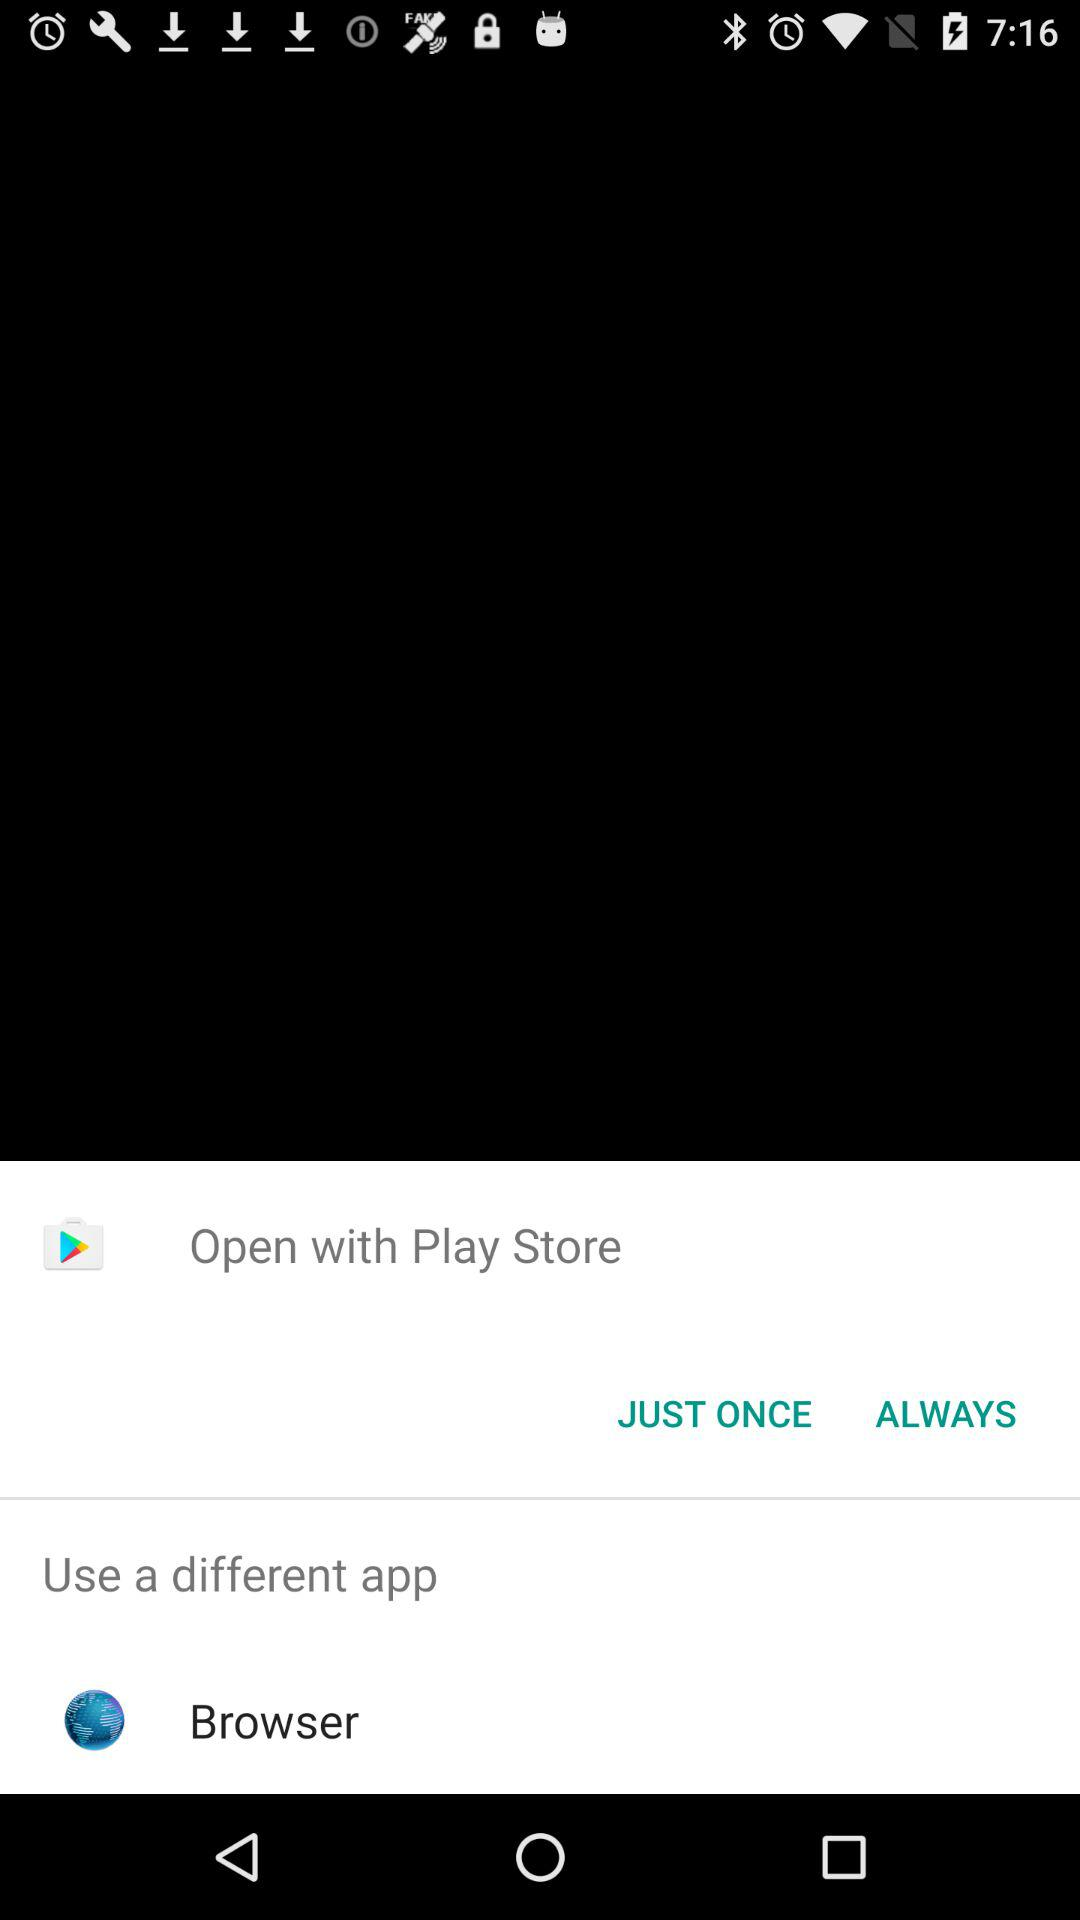What option can be used to open? The options that can be used to open are "Play Store" and "Browser". 